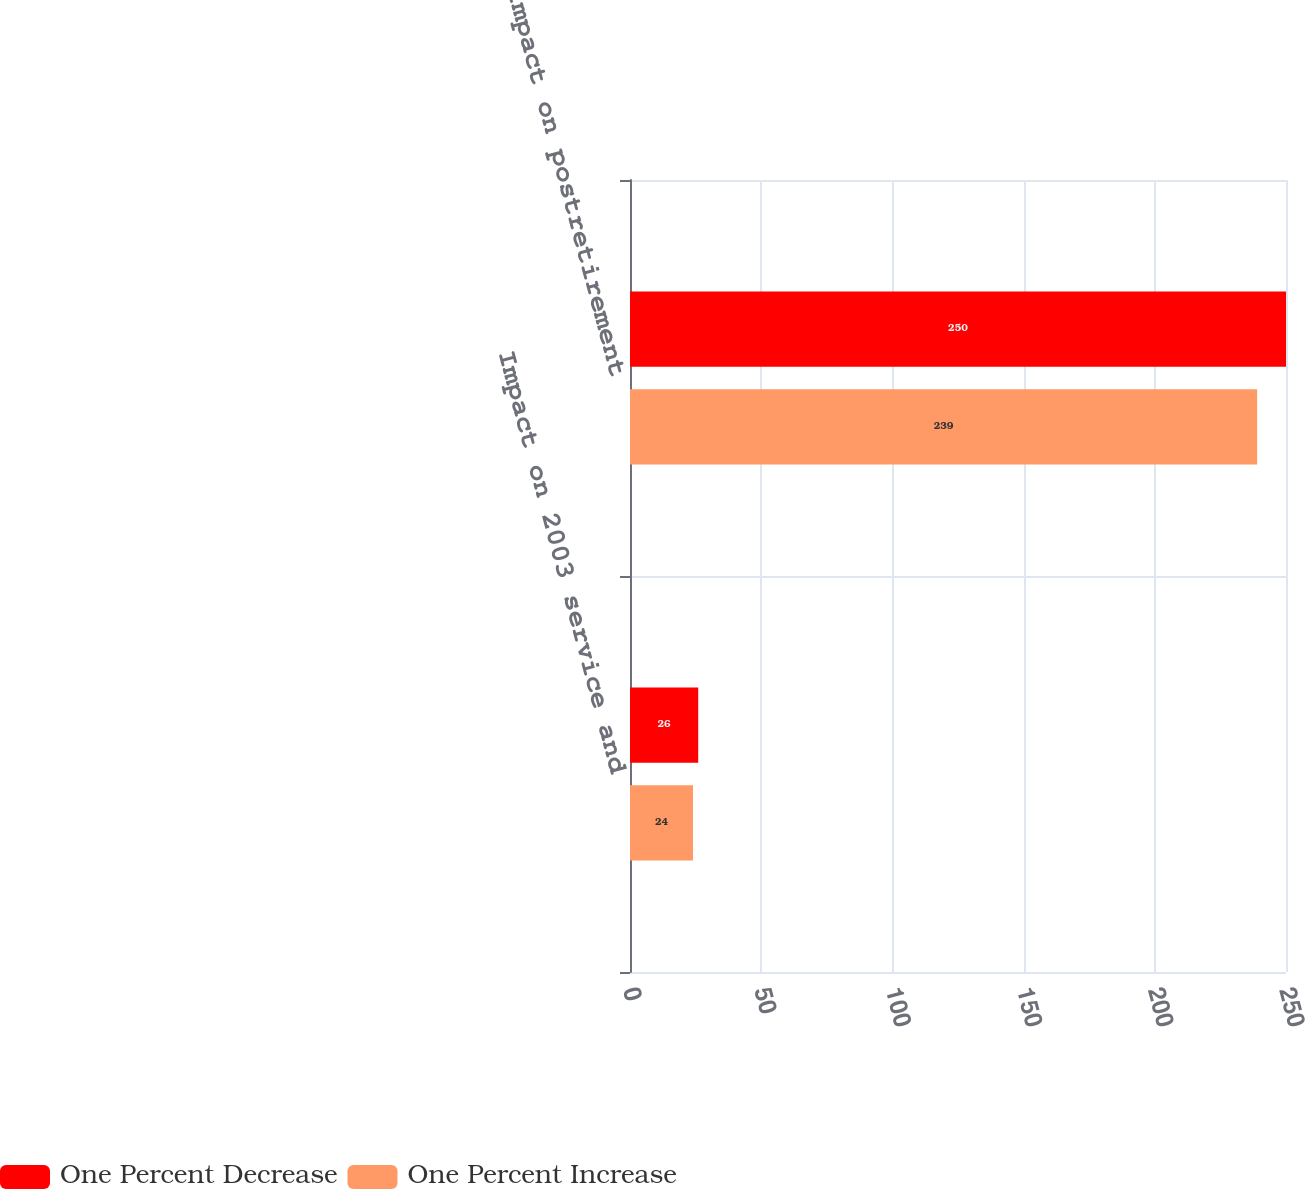<chart> <loc_0><loc_0><loc_500><loc_500><stacked_bar_chart><ecel><fcel>Impact on 2003 service and<fcel>Impact on postretirement<nl><fcel>One Percent Decrease<fcel>26<fcel>250<nl><fcel>One Percent Increase<fcel>24<fcel>239<nl></chart> 